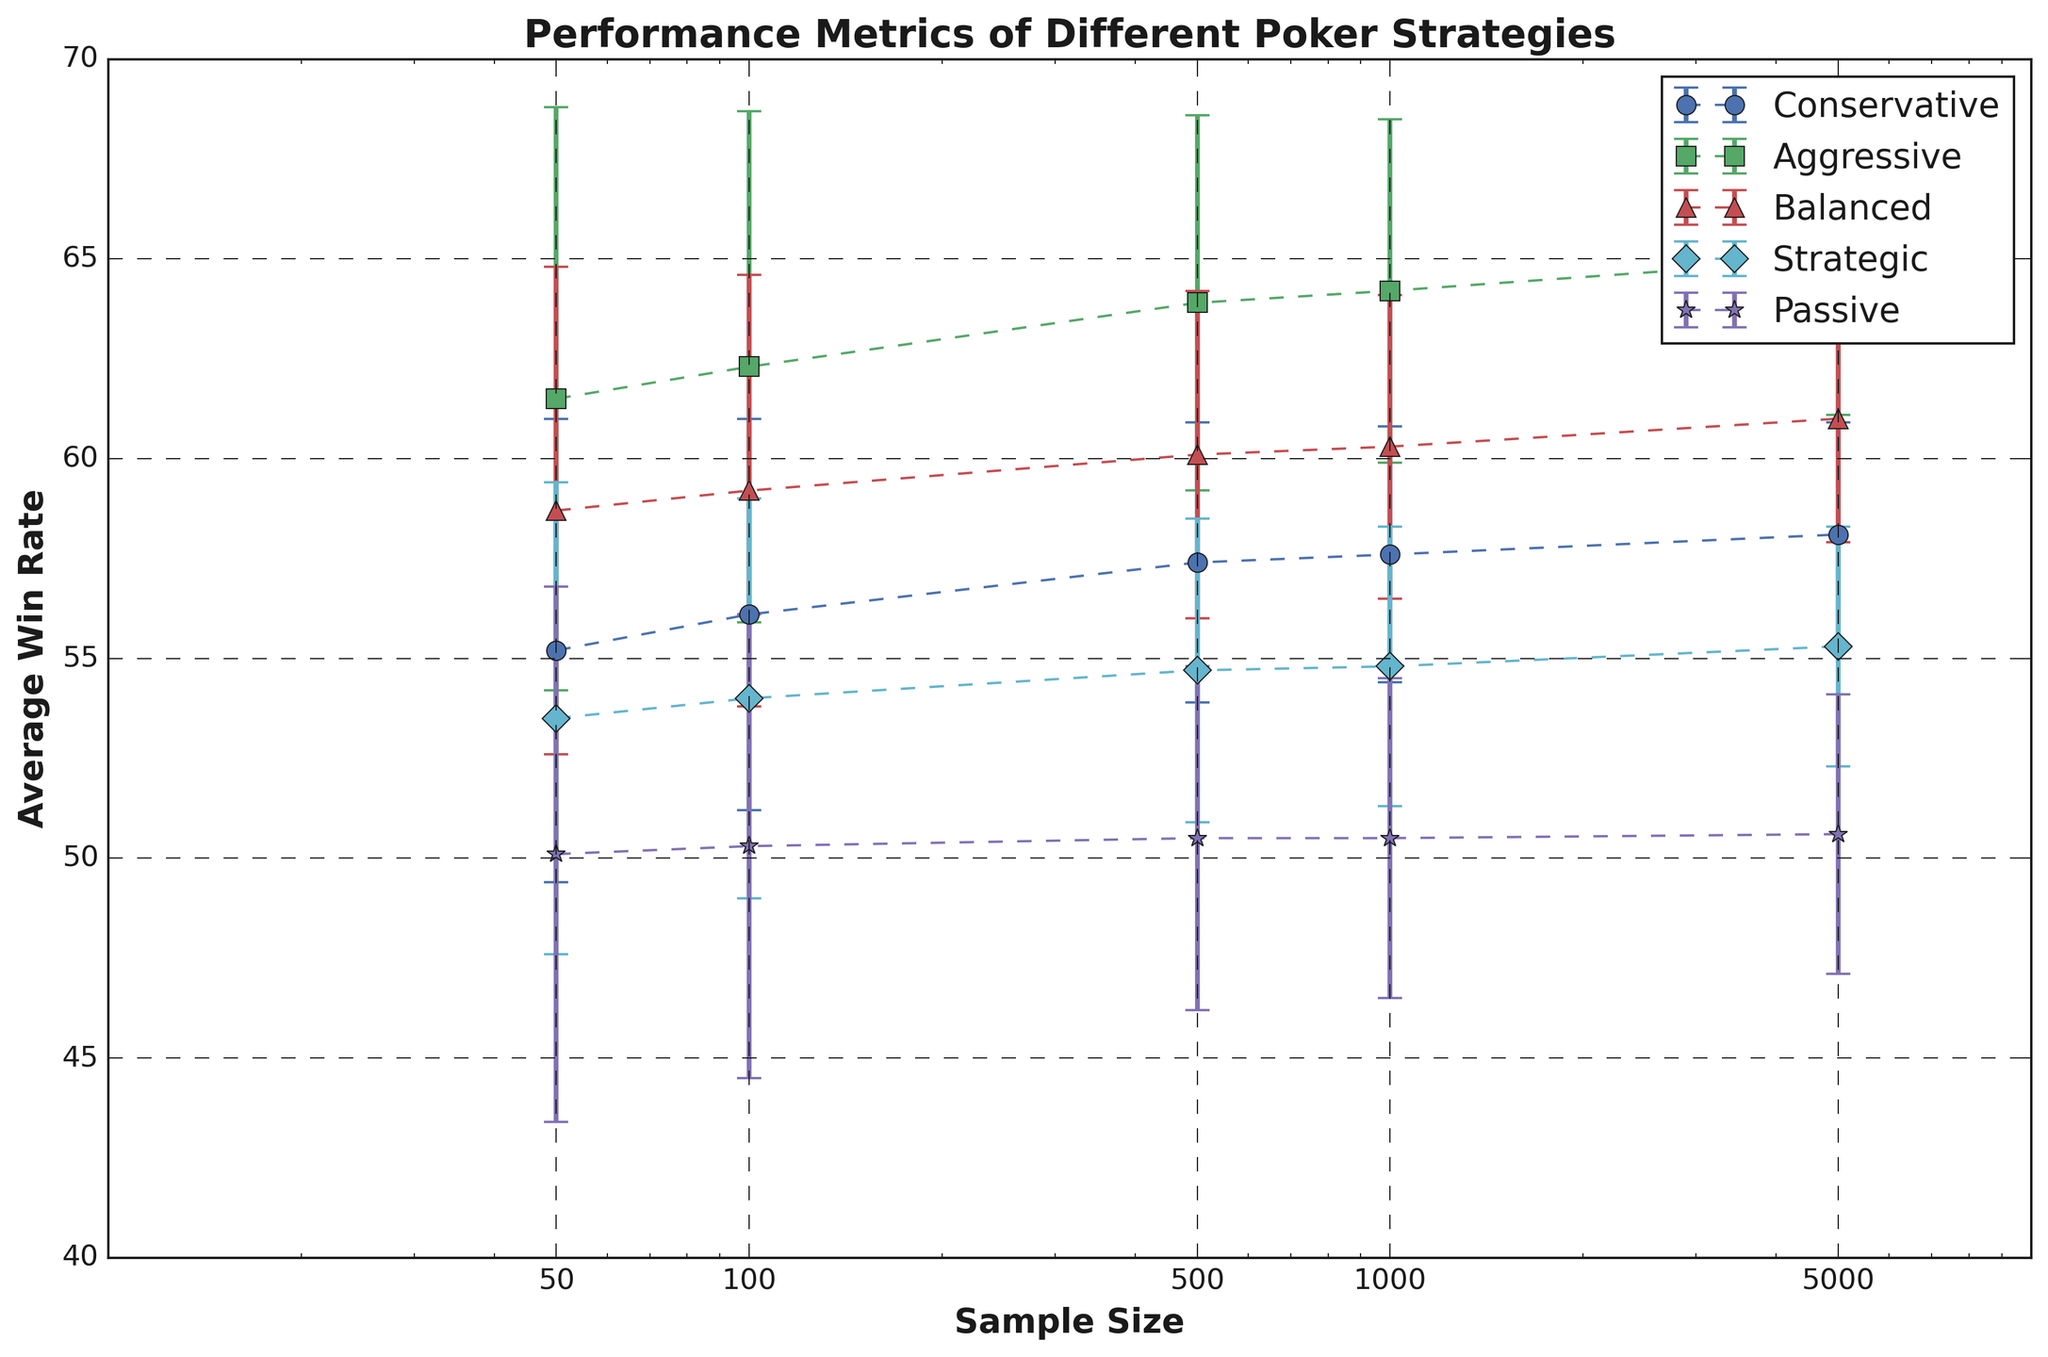How does the average win rate of the Conservative strategy change as the sample size increases? Looking at the visual trend for the Conservative strategy (blue line), the average win rate generally increases as the sample size increases from 50 to 5000.
Answer: It increases Which strategy has the highest win rate at a sample size of 100? Checking the data points at the sample size of 100, the red line (Aggressive strategy) is positioned the highest.
Answer: Aggressive Compare the standard deviation of the Conservative and Aggressive strategies at a sample size of 5000. Which one is higher? At a sample size of 5000, the error bars are shortest for Conservative and slightly longer for Aggressive, indicating that Aggressive has a higher standard deviation.
Answer: Aggressive How does the average win rate for the Balanced strategy at a sample size of 1000 compare to the Strategic strategy at the same sample size? The balanced strategy (green line) is higher than the Strategic strategy (magenta line) when the sample size is 1000.
Answer: Balanced is higher Which strategy maintains the smallest increase in average win rate from a sample size of 50 to 5000? Observing the slopes of the lines from sample size 50 to 5000, the Passive strategy (cyan line) shows the least increase, as it stays almost flat.
Answer: Passive What is the difference in average win rate between the Aggressive and Passive strategies at a sample size of 50? The Aggressive average win rate at 50 is 61.5, and Passive is 50.1. The difference is 61.5 - 50.1 = 11.4.
Answer: 11.4 Which strategy shows the highest fluctuation in its win rate, and at what sample size is this fluctuation observed? By comparing the lengths of error bars (standard deviation), the Aggressive strategy shows the highest fluctuation at a sample size of 50.
Answer: Aggressive at 50 How many strategies have a win rate over 60 at a sample size of 1000? From the figure at sample size 1000, Aggressive and Balanced strategies have win rates over 60. So, the number is 2.
Answer: 2 